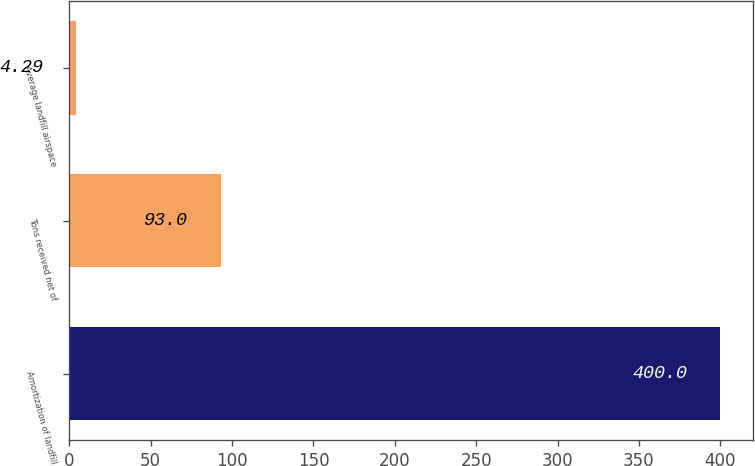Convert chart. <chart><loc_0><loc_0><loc_500><loc_500><bar_chart><fcel>Amortization of landfill<fcel>Tons received net of<fcel>Average landfill airspace<nl><fcel>400<fcel>93<fcel>4.29<nl></chart> 